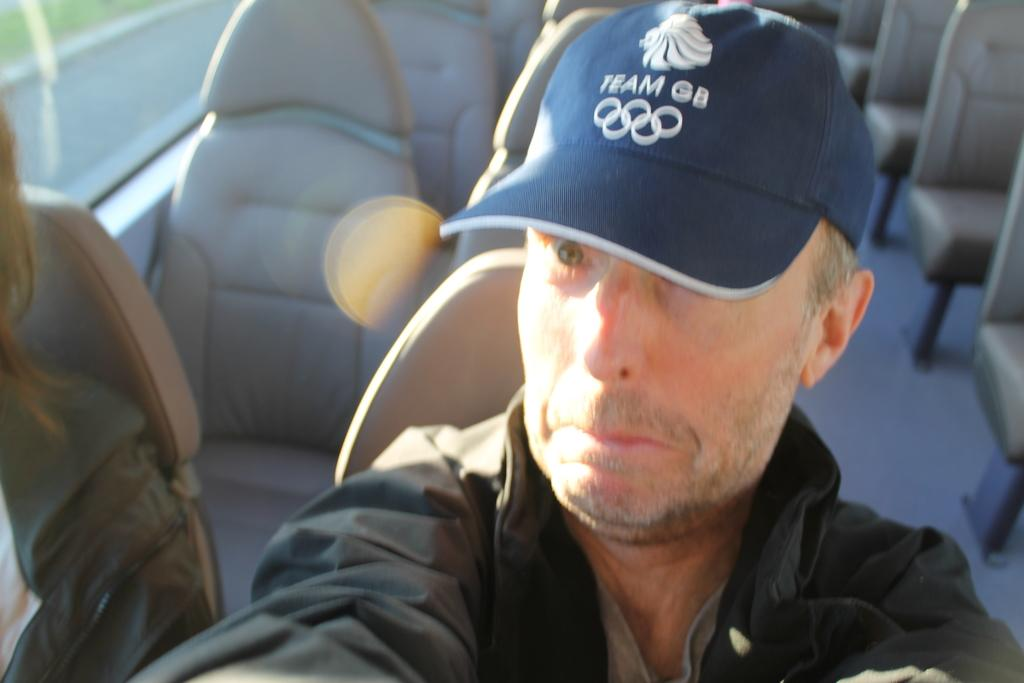What is the man doing in the image? The man is sitting in a vehicle. Can you describe the man's clothing in the image? The man is wearing a blue color cap and a grey color jacket. What type of distribution is the man responsible for in the image? There is no information about distribution in the image; the man is simply sitting in a vehicle. 